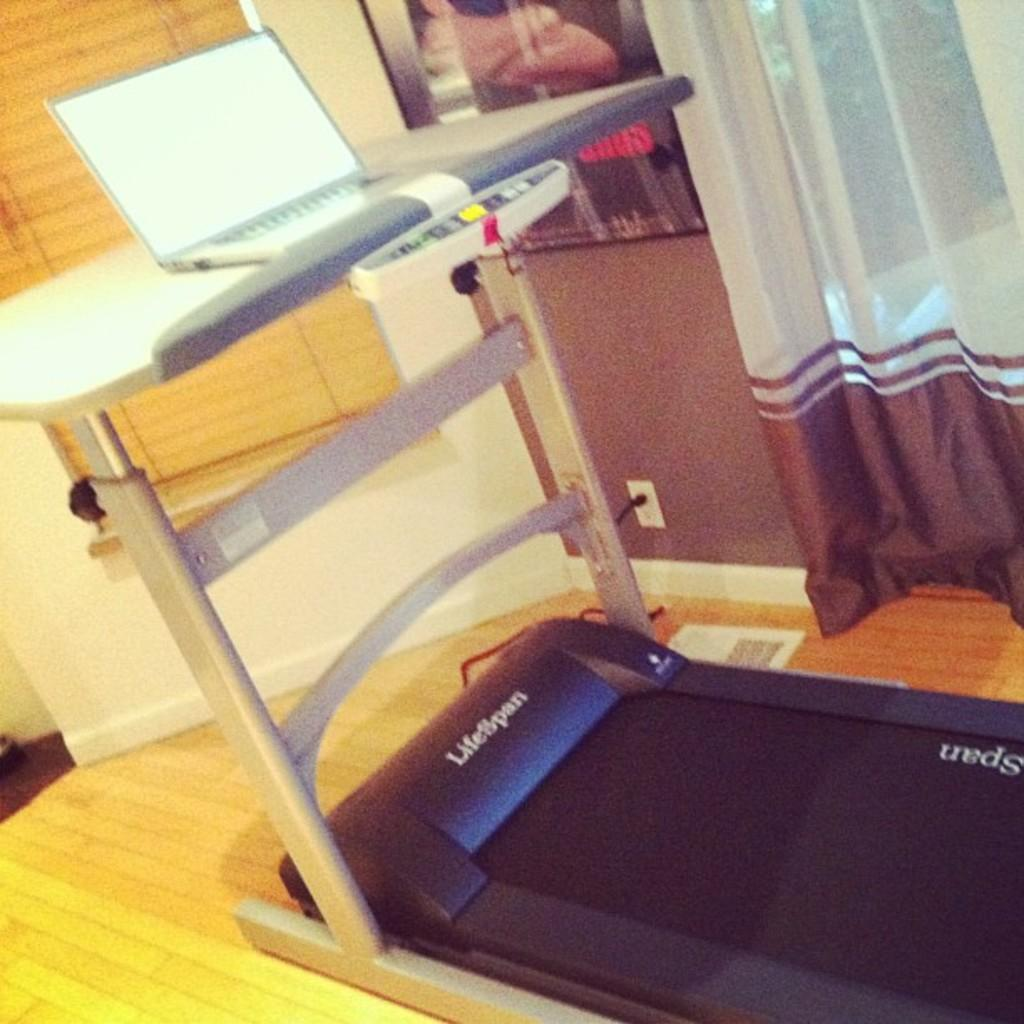What exercise equipment is visible in the image? There is: There is a treadmill in the image. What is placed on the treadmill? A laptop is placed on the treadmill. What type of window treatment is present in the image? Blinds are present near a window in the image. What can be seen on the wall in the image? There is a photo frame on the wall. What type of covering is present on the window? There is a curtain in the image. What type of pain is the person experiencing while using the treadmill in the image? There is no indication of pain in the image, and we cannot assume the person using the treadmill is experiencing any pain. 